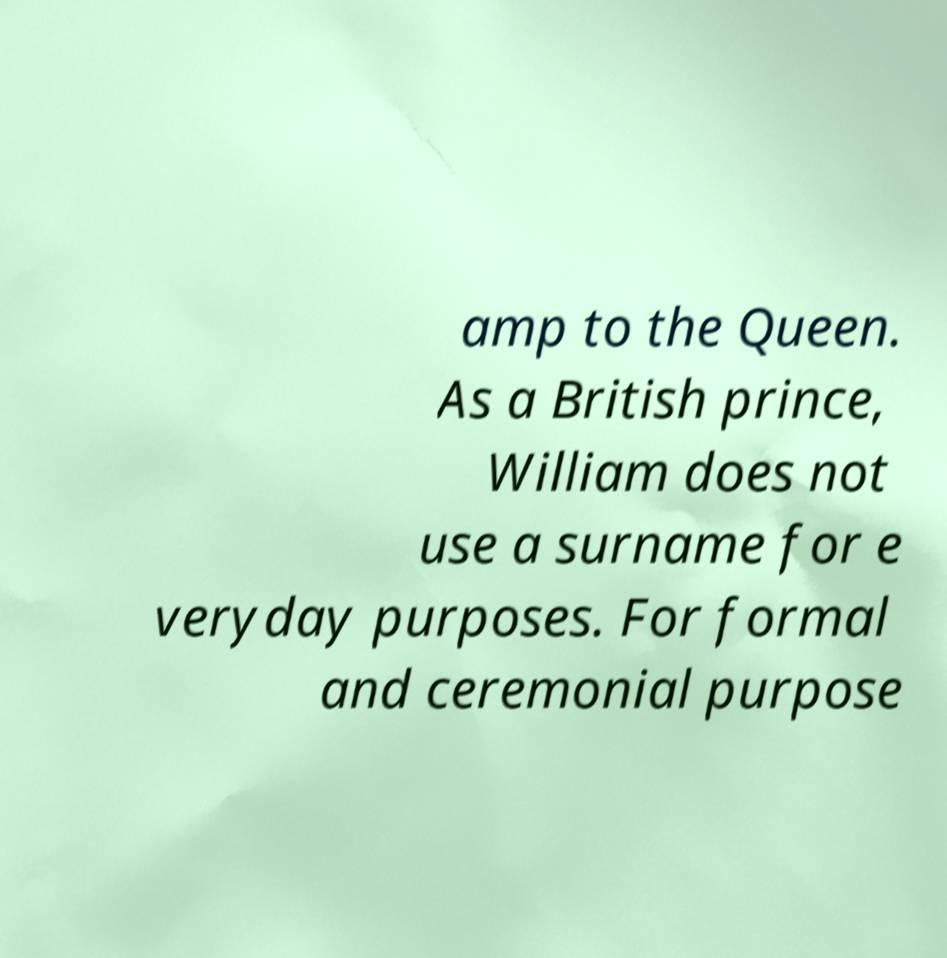What messages or text are displayed in this image? I need them in a readable, typed format. amp to the Queen. As a British prince, William does not use a surname for e veryday purposes. For formal and ceremonial purpose 